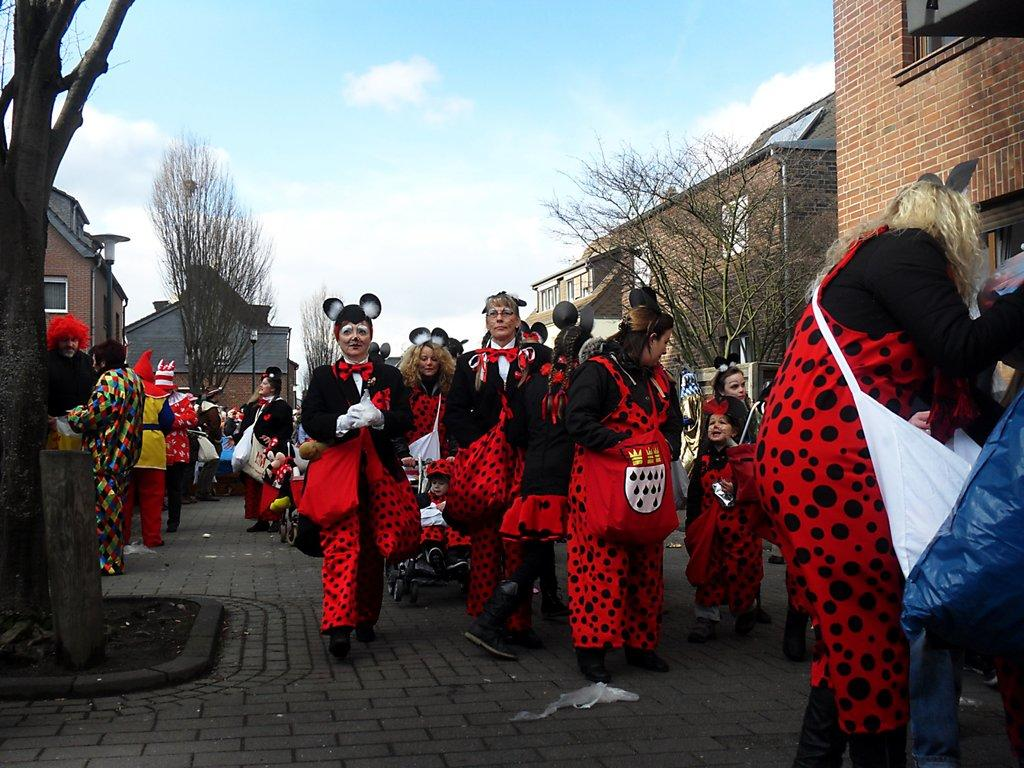What are the people in the center of the image doing? The people in the center of the image are wearing costumes. What can be seen in the background of the image? There are trees, buildings, and the sky visible in the background of the image. What type of quill is being used by the girl in the image? There is no girl or quill present in the image. 